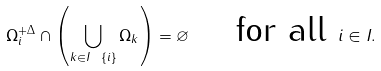Convert formula to latex. <formula><loc_0><loc_0><loc_500><loc_500>\Omega _ { i } ^ { + \Delta } \cap \left ( \bigcup _ { k \in I \ \{ i \} } \Omega _ { k } \right ) = \varnothing \quad \text { for all } i \in I .</formula> 